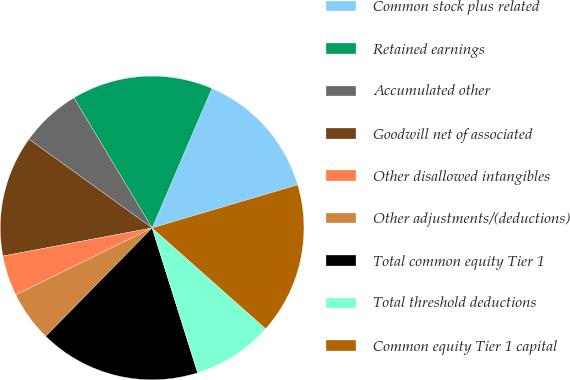<chart> <loc_0><loc_0><loc_500><loc_500><pie_chart><fcel>Common stock plus related<fcel>Retained earnings<fcel>Accumulated other<fcel>Goodwill net of associated<fcel>Other disallowed intangibles<fcel>Other adjustments/(deductions)<fcel>Total common equity Tier 1<fcel>Total threshold deductions<fcel>Common equity Tier 1 capital<nl><fcel>13.98%<fcel>15.05%<fcel>6.45%<fcel>12.9%<fcel>4.3%<fcel>5.38%<fcel>17.2%<fcel>8.6%<fcel>16.13%<nl></chart> 